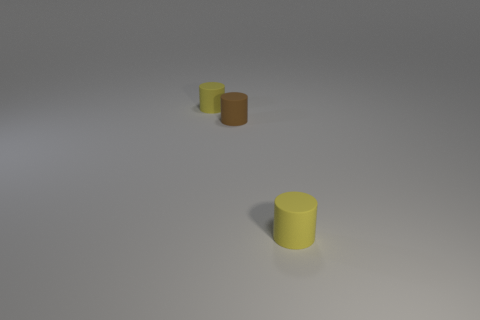Subtract all gray cylinders. Subtract all brown blocks. How many cylinders are left? 3 Add 2 tiny yellow metallic cubes. How many objects exist? 5 Subtract all tiny brown matte things. Subtract all small brown objects. How many objects are left? 1 Add 2 yellow rubber cylinders. How many yellow rubber cylinders are left? 4 Add 3 purple cylinders. How many purple cylinders exist? 3 Subtract 0 brown balls. How many objects are left? 3 